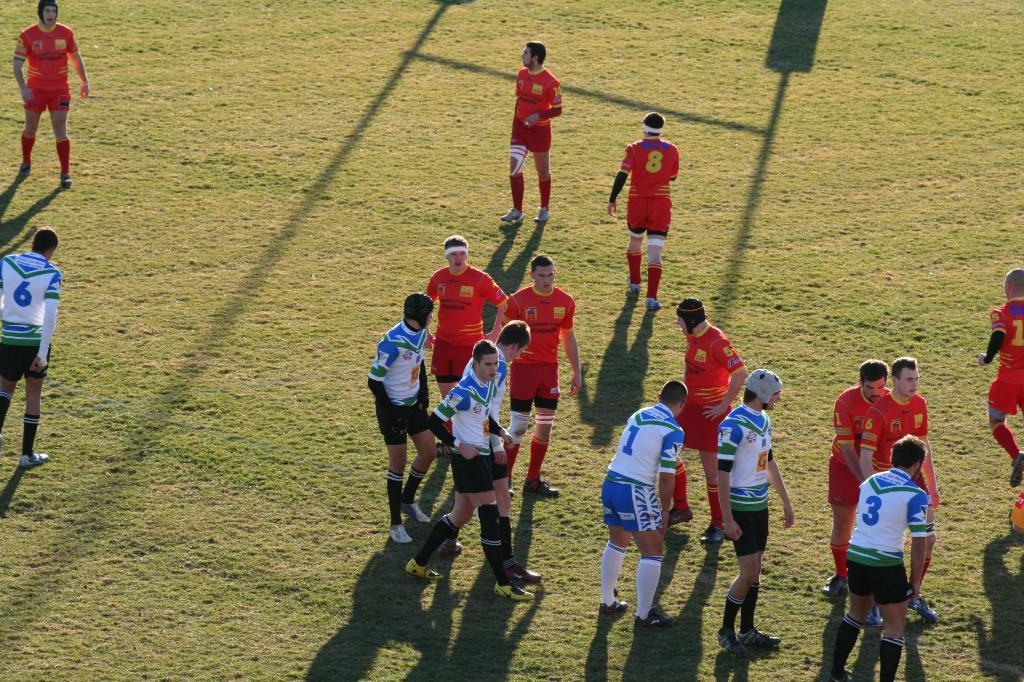<image>
Give a short and clear explanation of the subsequent image. white and blue vs red teams on a grass field with number 1 on white/blue team leaned foward a bit 